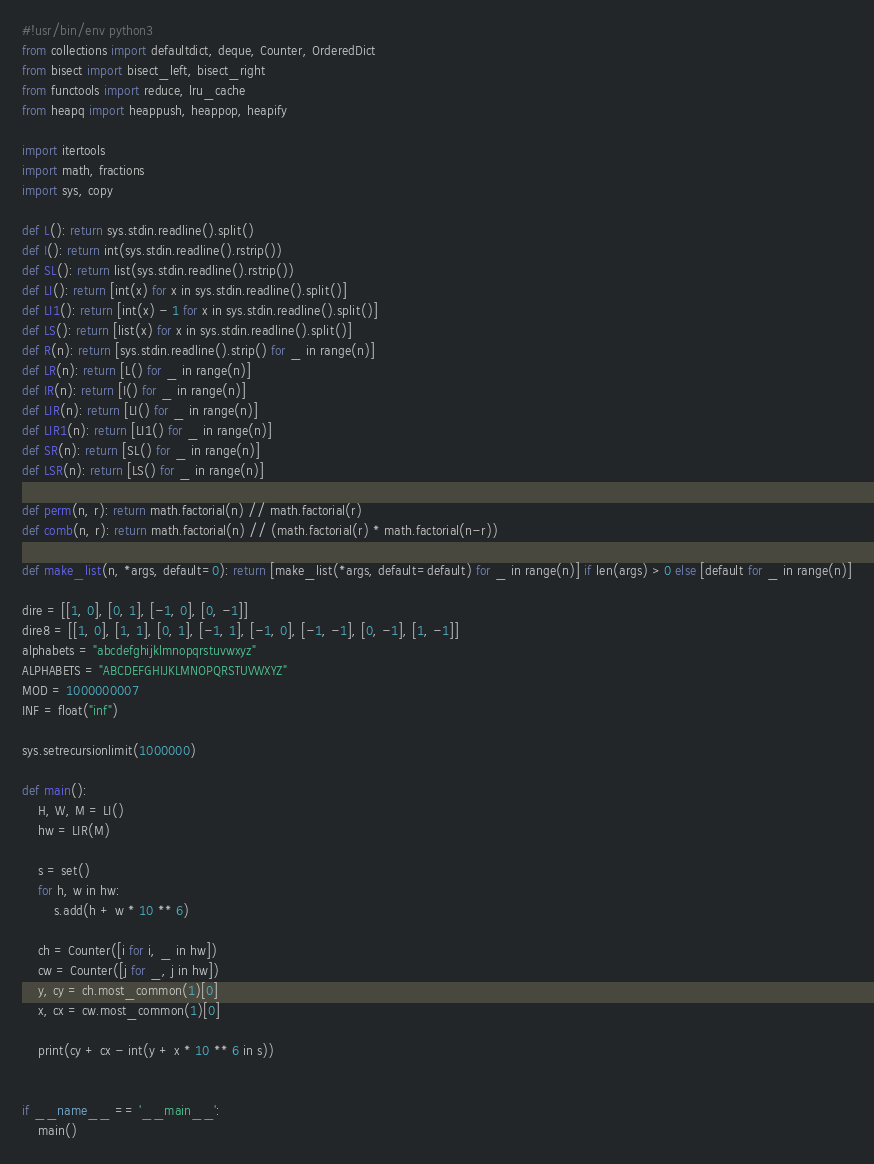<code> <loc_0><loc_0><loc_500><loc_500><_Python_>#!usr/bin/env python3
from collections import defaultdict, deque, Counter, OrderedDict
from bisect import bisect_left, bisect_right
from functools import reduce, lru_cache
from heapq import heappush, heappop, heapify

import itertools
import math, fractions
import sys, copy

def L(): return sys.stdin.readline().split()
def I(): return int(sys.stdin.readline().rstrip())
def SL(): return list(sys.stdin.readline().rstrip())
def LI(): return [int(x) for x in sys.stdin.readline().split()]
def LI1(): return [int(x) - 1 for x in sys.stdin.readline().split()]
def LS(): return [list(x) for x in sys.stdin.readline().split()]
def R(n): return [sys.stdin.readline().strip() for _ in range(n)]
def LR(n): return [L() for _ in range(n)]
def IR(n): return [I() for _ in range(n)]
def LIR(n): return [LI() for _ in range(n)]
def LIR1(n): return [LI1() for _ in range(n)]
def SR(n): return [SL() for _ in range(n)]
def LSR(n): return [LS() for _ in range(n)]

def perm(n, r): return math.factorial(n) // math.factorial(r)
def comb(n, r): return math.factorial(n) // (math.factorial(r) * math.factorial(n-r))

def make_list(n, *args, default=0): return [make_list(*args, default=default) for _ in range(n)] if len(args) > 0 else [default for _ in range(n)]

dire = [[1, 0], [0, 1], [-1, 0], [0, -1]]
dire8 = [[1, 0], [1, 1], [0, 1], [-1, 1], [-1, 0], [-1, -1], [0, -1], [1, -1]]
alphabets = "abcdefghijklmnopqrstuvwxyz"
ALPHABETS = "ABCDEFGHIJKLMNOPQRSTUVWXYZ"
MOD = 1000000007
INF = float("inf")

sys.setrecursionlimit(1000000)

def main():
    H, W, M = LI()
    hw = LIR(M)

    s = set()
    for h, w in hw:
        s.add(h + w * 10 ** 6)

    ch = Counter([i for i, _ in hw])
    cw = Counter([j for _, j in hw])
    y, cy = ch.most_common(1)[0]
    x, cx = cw.most_common(1)[0]

    print(cy + cx - int(y + x * 10 ** 6 in s))


if __name__ == '__main__':
    main()</code> 